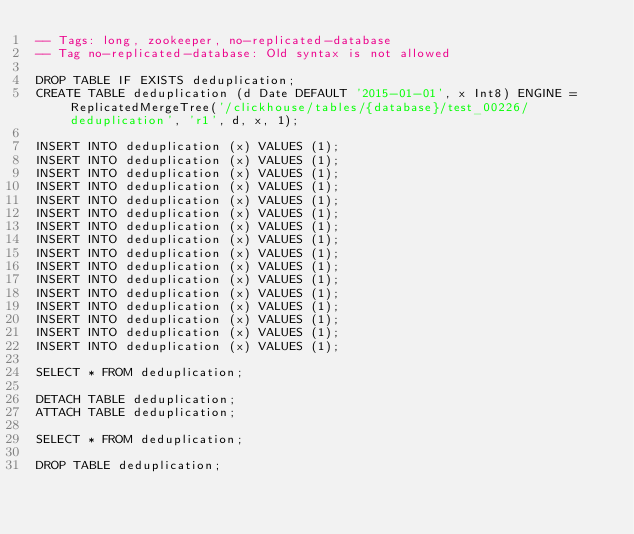<code> <loc_0><loc_0><loc_500><loc_500><_SQL_>-- Tags: long, zookeeper, no-replicated-database
-- Tag no-replicated-database: Old syntax is not allowed

DROP TABLE IF EXISTS deduplication;
CREATE TABLE deduplication (d Date DEFAULT '2015-01-01', x Int8) ENGINE = ReplicatedMergeTree('/clickhouse/tables/{database}/test_00226/deduplication', 'r1', d, x, 1);

INSERT INTO deduplication (x) VALUES (1);
INSERT INTO deduplication (x) VALUES (1);
INSERT INTO deduplication (x) VALUES (1);
INSERT INTO deduplication (x) VALUES (1);
INSERT INTO deduplication (x) VALUES (1);
INSERT INTO deduplication (x) VALUES (1);
INSERT INTO deduplication (x) VALUES (1);
INSERT INTO deduplication (x) VALUES (1);
INSERT INTO deduplication (x) VALUES (1);
INSERT INTO deduplication (x) VALUES (1);
INSERT INTO deduplication (x) VALUES (1);
INSERT INTO deduplication (x) VALUES (1);
INSERT INTO deduplication (x) VALUES (1);
INSERT INTO deduplication (x) VALUES (1);
INSERT INTO deduplication (x) VALUES (1);
INSERT INTO deduplication (x) VALUES (1);

SELECT * FROM deduplication;

DETACH TABLE deduplication;
ATTACH TABLE deduplication;

SELECT * FROM deduplication;

DROP TABLE deduplication;
</code> 